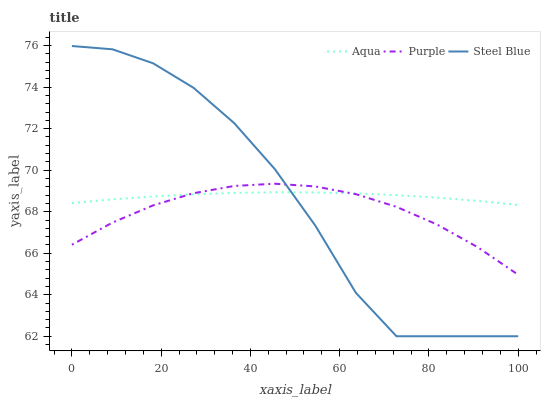Does Purple have the minimum area under the curve?
Answer yes or no. Yes. Does Aqua have the maximum area under the curve?
Answer yes or no. Yes. Does Steel Blue have the minimum area under the curve?
Answer yes or no. No. Does Steel Blue have the maximum area under the curve?
Answer yes or no. No. Is Aqua the smoothest?
Answer yes or no. Yes. Is Steel Blue the roughest?
Answer yes or no. Yes. Is Steel Blue the smoothest?
Answer yes or no. No. Is Aqua the roughest?
Answer yes or no. No. Does Steel Blue have the lowest value?
Answer yes or no. Yes. Does Aqua have the lowest value?
Answer yes or no. No. Does Steel Blue have the highest value?
Answer yes or no. Yes. Does Aqua have the highest value?
Answer yes or no. No. Does Steel Blue intersect Aqua?
Answer yes or no. Yes. Is Steel Blue less than Aqua?
Answer yes or no. No. Is Steel Blue greater than Aqua?
Answer yes or no. No. 